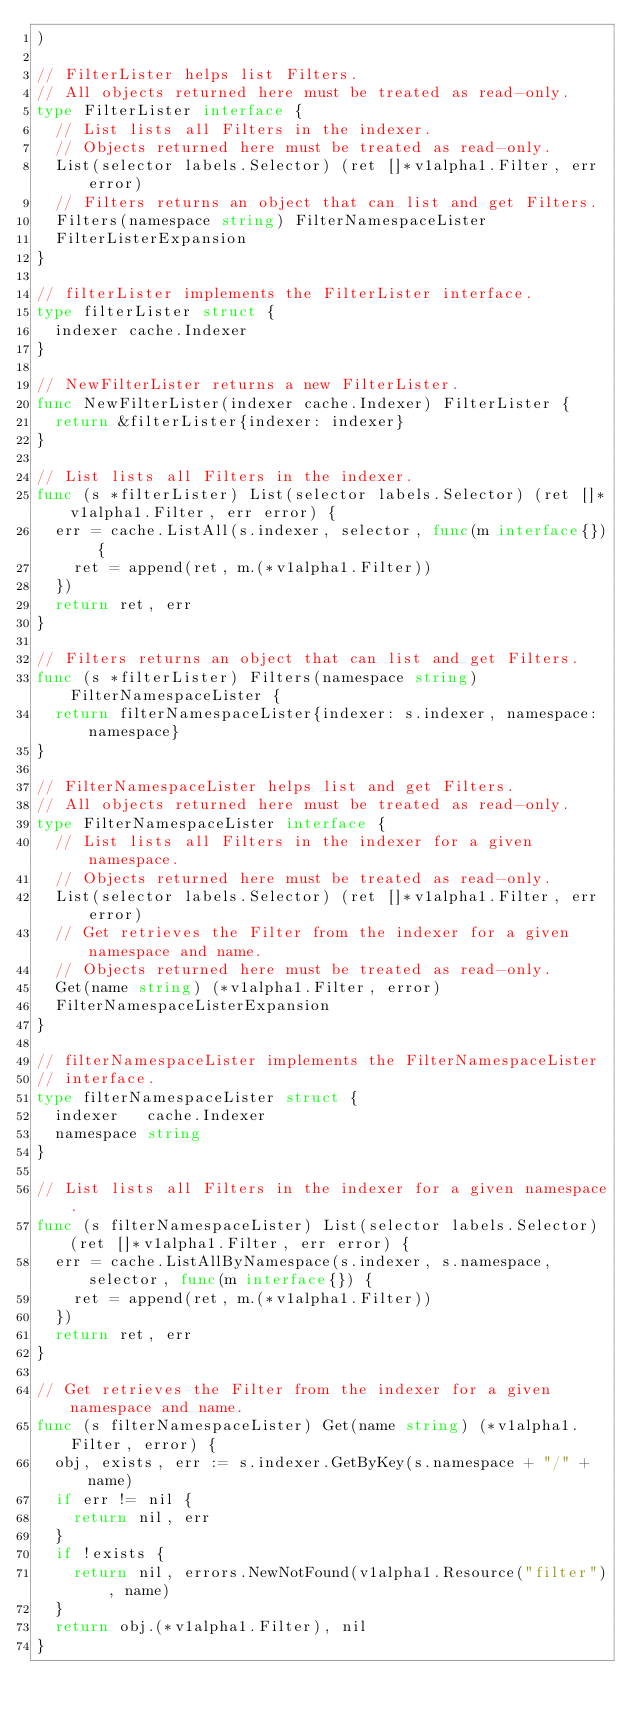Convert code to text. <code><loc_0><loc_0><loc_500><loc_500><_Go_>)

// FilterLister helps list Filters.
// All objects returned here must be treated as read-only.
type FilterLister interface {
	// List lists all Filters in the indexer.
	// Objects returned here must be treated as read-only.
	List(selector labels.Selector) (ret []*v1alpha1.Filter, err error)
	// Filters returns an object that can list and get Filters.
	Filters(namespace string) FilterNamespaceLister
	FilterListerExpansion
}

// filterLister implements the FilterLister interface.
type filterLister struct {
	indexer cache.Indexer
}

// NewFilterLister returns a new FilterLister.
func NewFilterLister(indexer cache.Indexer) FilterLister {
	return &filterLister{indexer: indexer}
}

// List lists all Filters in the indexer.
func (s *filterLister) List(selector labels.Selector) (ret []*v1alpha1.Filter, err error) {
	err = cache.ListAll(s.indexer, selector, func(m interface{}) {
		ret = append(ret, m.(*v1alpha1.Filter))
	})
	return ret, err
}

// Filters returns an object that can list and get Filters.
func (s *filterLister) Filters(namespace string) FilterNamespaceLister {
	return filterNamespaceLister{indexer: s.indexer, namespace: namespace}
}

// FilterNamespaceLister helps list and get Filters.
// All objects returned here must be treated as read-only.
type FilterNamespaceLister interface {
	// List lists all Filters in the indexer for a given namespace.
	// Objects returned here must be treated as read-only.
	List(selector labels.Selector) (ret []*v1alpha1.Filter, err error)
	// Get retrieves the Filter from the indexer for a given namespace and name.
	// Objects returned here must be treated as read-only.
	Get(name string) (*v1alpha1.Filter, error)
	FilterNamespaceListerExpansion
}

// filterNamespaceLister implements the FilterNamespaceLister
// interface.
type filterNamespaceLister struct {
	indexer   cache.Indexer
	namespace string
}

// List lists all Filters in the indexer for a given namespace.
func (s filterNamespaceLister) List(selector labels.Selector) (ret []*v1alpha1.Filter, err error) {
	err = cache.ListAllByNamespace(s.indexer, s.namespace, selector, func(m interface{}) {
		ret = append(ret, m.(*v1alpha1.Filter))
	})
	return ret, err
}

// Get retrieves the Filter from the indexer for a given namespace and name.
func (s filterNamespaceLister) Get(name string) (*v1alpha1.Filter, error) {
	obj, exists, err := s.indexer.GetByKey(s.namespace + "/" + name)
	if err != nil {
		return nil, err
	}
	if !exists {
		return nil, errors.NewNotFound(v1alpha1.Resource("filter"), name)
	}
	return obj.(*v1alpha1.Filter), nil
}
</code> 